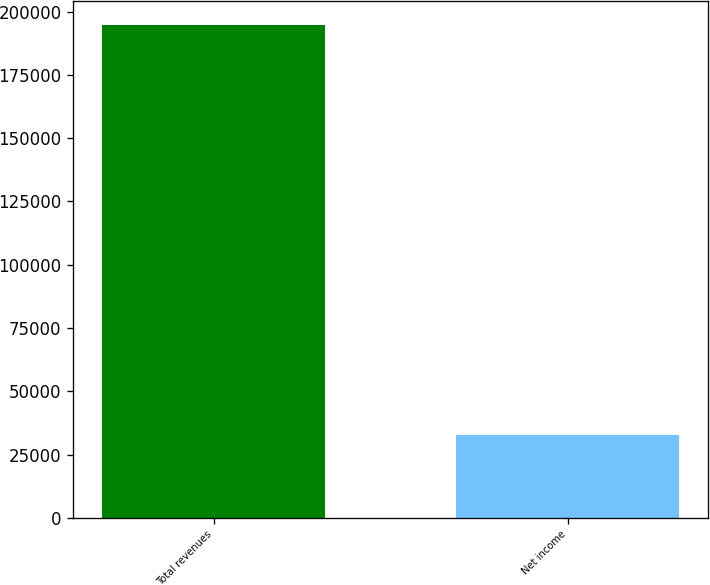<chart> <loc_0><loc_0><loc_500><loc_500><bar_chart><fcel>Total revenues<fcel>Net income<nl><fcel>194578<fcel>32686<nl></chart> 